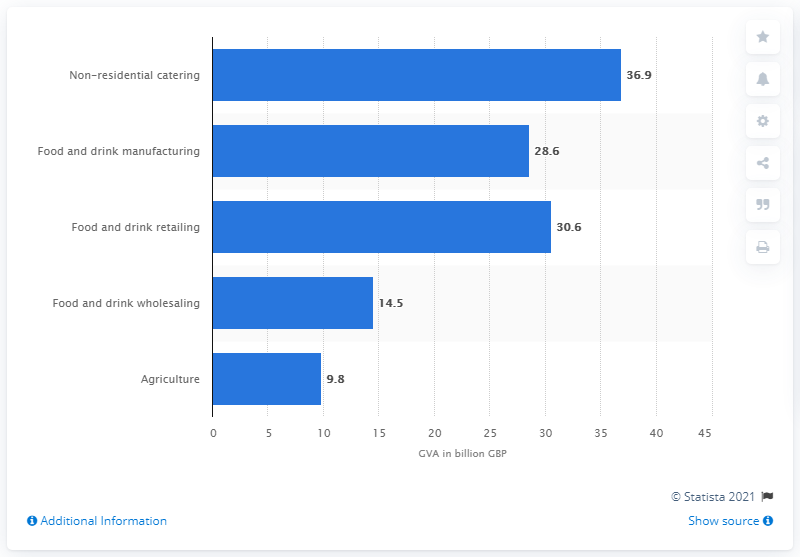Outline some significant characteristics in this image. In 2018, non-residential catering made a significant contribution to the national gross value added, with a value of 36.9%. 